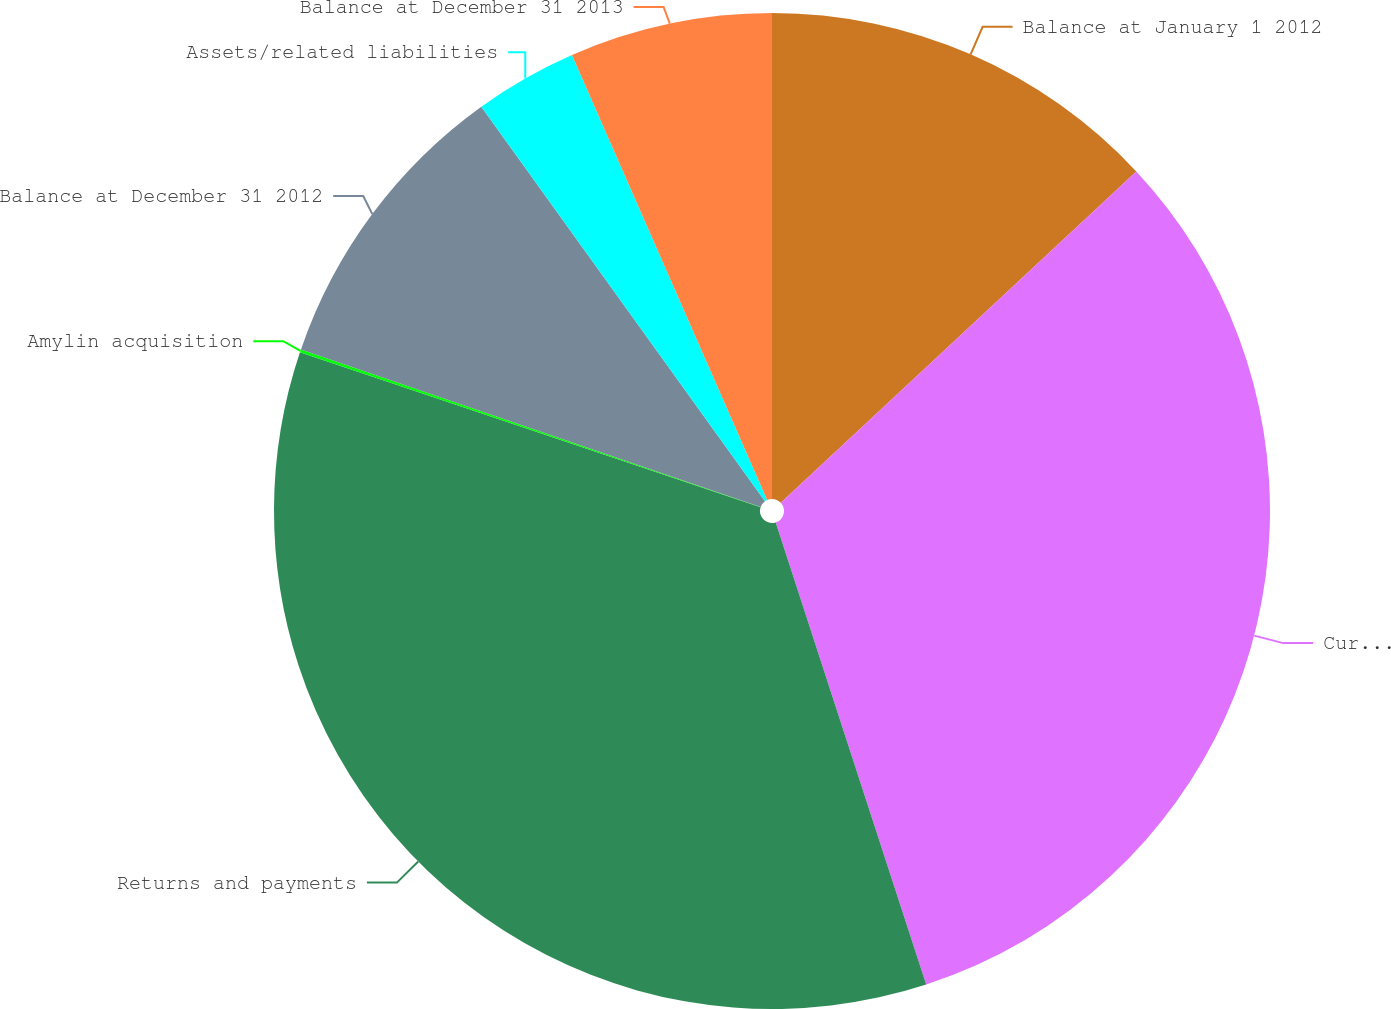Convert chart. <chart><loc_0><loc_0><loc_500><loc_500><pie_chart><fcel>Balance at January 1 2012<fcel>Current period<fcel>Returns and payments<fcel>Amylin acquisition<fcel>Balance at December 31 2012<fcel>Assets/related liabilities<fcel>Balance at December 31 2013<nl><fcel>13.06%<fcel>31.93%<fcel>35.17%<fcel>0.1%<fcel>9.82%<fcel>3.34%<fcel>6.58%<nl></chart> 